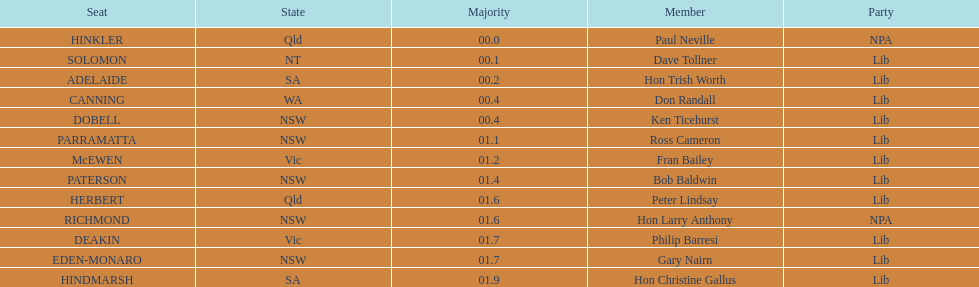Was fran bailey from victoria or western australia? Vic. 